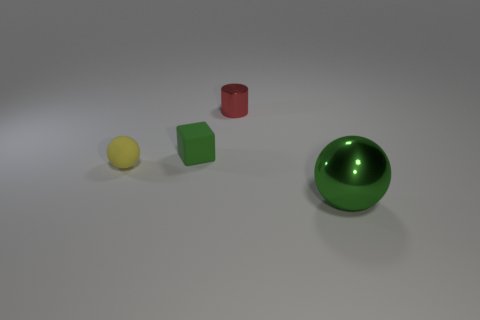Add 4 red cylinders. How many objects exist? 8 Subtract all blocks. How many objects are left? 3 Subtract all tiny yellow rubber objects. Subtract all tiny yellow rubber objects. How many objects are left? 2 Add 1 green cubes. How many green cubes are left? 2 Add 3 red metallic objects. How many red metallic objects exist? 4 Subtract 1 yellow spheres. How many objects are left? 3 